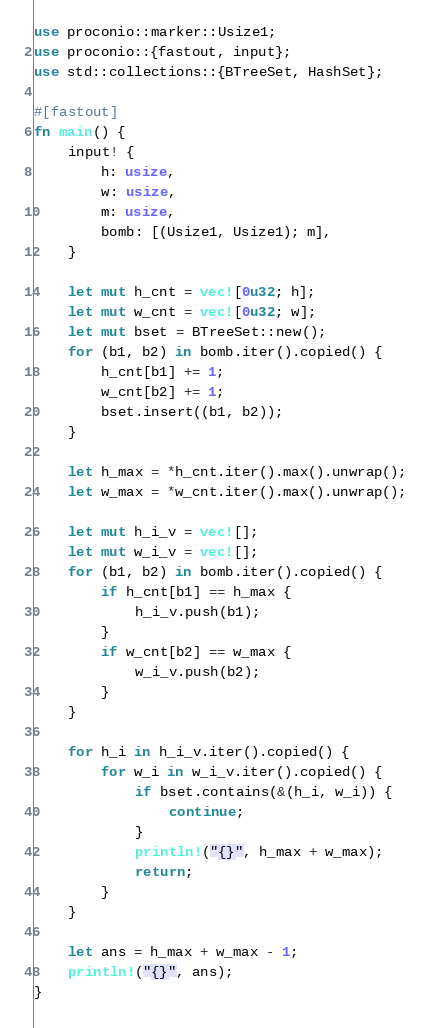Convert code to text. <code><loc_0><loc_0><loc_500><loc_500><_Rust_>use proconio::marker::Usize1;
use proconio::{fastout, input};
use std::collections::{BTreeSet, HashSet};

#[fastout]
fn main() {
    input! {
        h: usize,
        w: usize,
        m: usize,
        bomb: [(Usize1, Usize1); m],
    }

    let mut h_cnt = vec![0u32; h];
    let mut w_cnt = vec![0u32; w];
    let mut bset = BTreeSet::new();
    for (b1, b2) in bomb.iter().copied() {
        h_cnt[b1] += 1;
        w_cnt[b2] += 1;
        bset.insert((b1, b2));
    }

    let h_max = *h_cnt.iter().max().unwrap();
    let w_max = *w_cnt.iter().max().unwrap();

    let mut h_i_v = vec![];
    let mut w_i_v = vec![];
    for (b1, b2) in bomb.iter().copied() {
        if h_cnt[b1] == h_max {
            h_i_v.push(b1);
        }
        if w_cnt[b2] == w_max {
            w_i_v.push(b2);
        }
    }

    for h_i in h_i_v.iter().copied() {
        for w_i in w_i_v.iter().copied() {
            if bset.contains(&(h_i, w_i)) {
                continue;
            }
            println!("{}", h_max + w_max);
            return;
        }
    }

    let ans = h_max + w_max - 1;
    println!("{}", ans);
}
</code> 